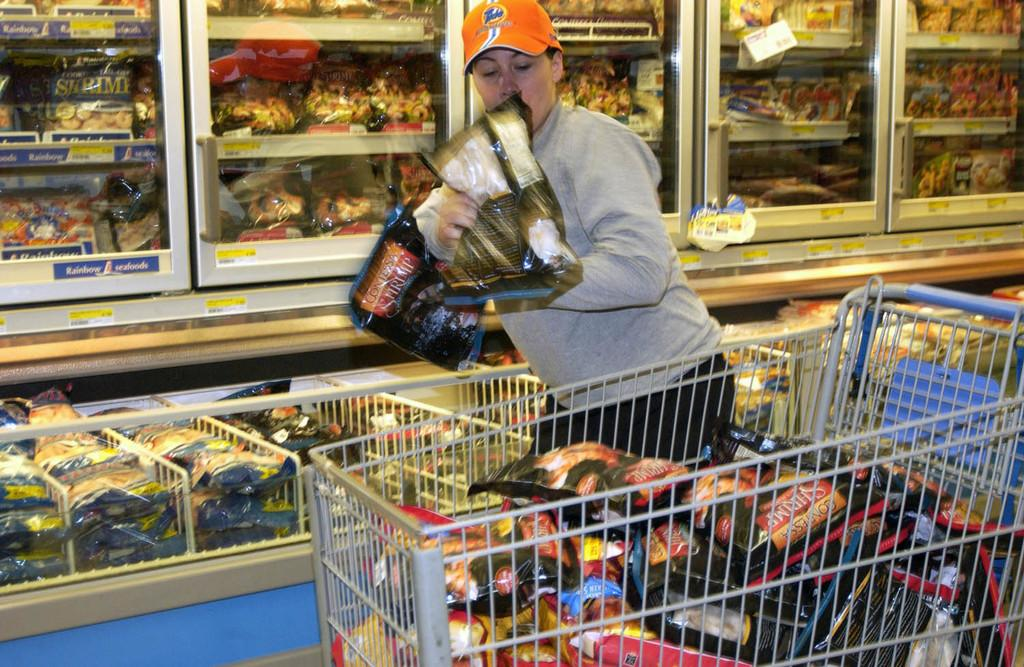<image>
Summarize the visual content of the image. A man is loading up his cart with frozen shrimp. 